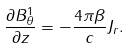Convert formula to latex. <formula><loc_0><loc_0><loc_500><loc_500>\frac { \partial B _ { \theta } ^ { 1 } } { \partial z } = - \frac { 4 \pi \beta } { c } J _ { r } .</formula> 